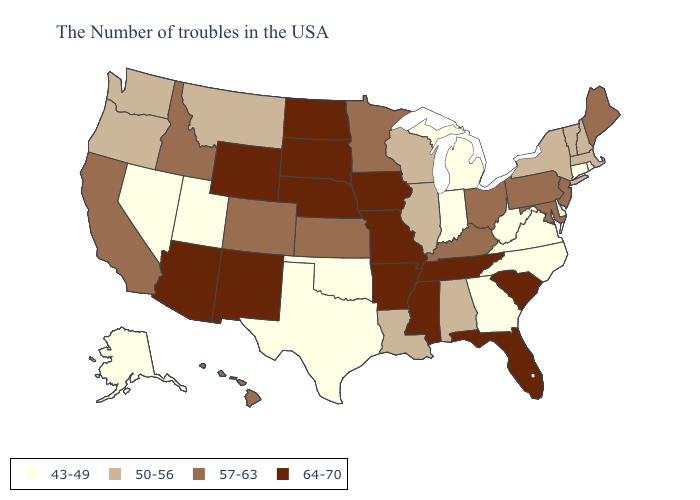Does North Dakota have the highest value in the USA?
Answer briefly. Yes. Does Washington have the same value as Kentucky?
Write a very short answer. No. Name the states that have a value in the range 57-63?
Be succinct. Maine, New Jersey, Maryland, Pennsylvania, Ohio, Kentucky, Minnesota, Kansas, Colorado, Idaho, California, Hawaii. What is the value of Georgia?
Give a very brief answer. 43-49. Does Maine have the lowest value in the USA?
Be succinct. No. What is the lowest value in the USA?
Quick response, please. 43-49. What is the lowest value in the Northeast?
Write a very short answer. 43-49. Does Alaska have the highest value in the USA?
Answer briefly. No. What is the lowest value in the South?
Be succinct. 43-49. Is the legend a continuous bar?
Keep it brief. No. Name the states that have a value in the range 57-63?
Write a very short answer. Maine, New Jersey, Maryland, Pennsylvania, Ohio, Kentucky, Minnesota, Kansas, Colorado, Idaho, California, Hawaii. Which states hav the highest value in the West?
Answer briefly. Wyoming, New Mexico, Arizona. Name the states that have a value in the range 57-63?
Short answer required. Maine, New Jersey, Maryland, Pennsylvania, Ohio, Kentucky, Minnesota, Kansas, Colorado, Idaho, California, Hawaii. What is the highest value in the USA?
Answer briefly. 64-70. Does North Carolina have the lowest value in the South?
Short answer required. Yes. 